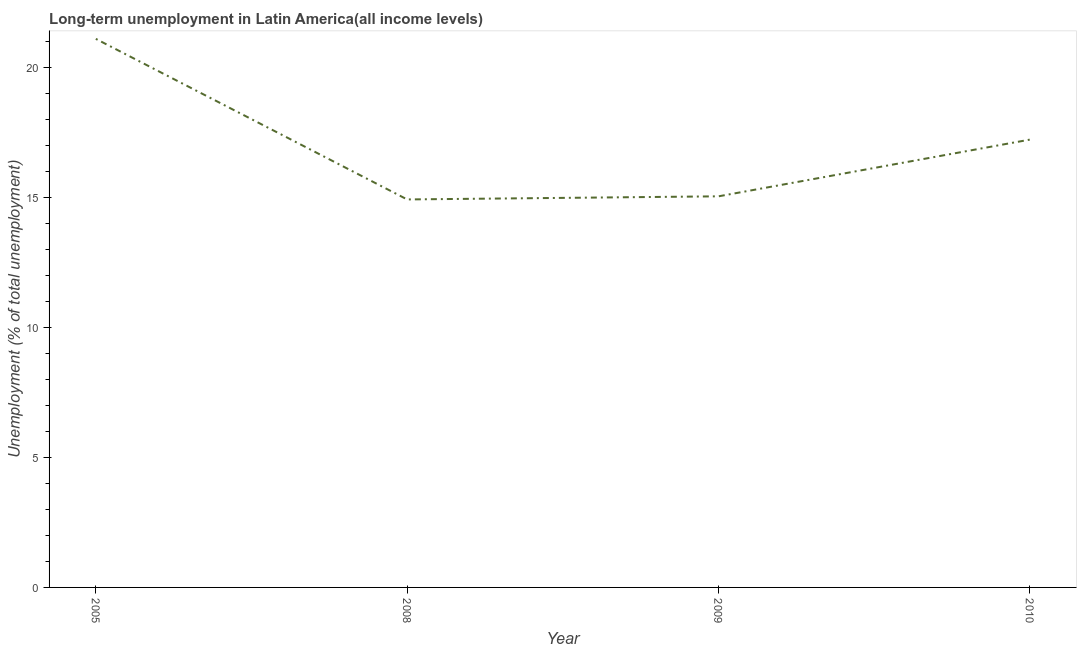What is the long-term unemployment in 2009?
Your answer should be very brief. 15.05. Across all years, what is the maximum long-term unemployment?
Provide a short and direct response. 21.11. Across all years, what is the minimum long-term unemployment?
Your response must be concise. 14.93. In which year was the long-term unemployment minimum?
Provide a succinct answer. 2008. What is the sum of the long-term unemployment?
Keep it short and to the point. 68.32. What is the difference between the long-term unemployment in 2005 and 2009?
Ensure brevity in your answer.  6.06. What is the average long-term unemployment per year?
Give a very brief answer. 17.08. What is the median long-term unemployment?
Offer a terse response. 16.14. Do a majority of the years between 2009 and 2005 (inclusive) have long-term unemployment greater than 19 %?
Make the answer very short. No. What is the ratio of the long-term unemployment in 2009 to that in 2010?
Your answer should be very brief. 0.87. What is the difference between the highest and the second highest long-term unemployment?
Provide a short and direct response. 3.88. Is the sum of the long-term unemployment in 2005 and 2009 greater than the maximum long-term unemployment across all years?
Offer a very short reply. Yes. What is the difference between the highest and the lowest long-term unemployment?
Make the answer very short. 6.18. How many lines are there?
Your answer should be very brief. 1. Are the values on the major ticks of Y-axis written in scientific E-notation?
Keep it short and to the point. No. Does the graph contain grids?
Provide a short and direct response. No. What is the title of the graph?
Your answer should be compact. Long-term unemployment in Latin America(all income levels). What is the label or title of the Y-axis?
Ensure brevity in your answer.  Unemployment (% of total unemployment). What is the Unemployment (% of total unemployment) in 2005?
Provide a succinct answer. 21.11. What is the Unemployment (% of total unemployment) in 2008?
Offer a very short reply. 14.93. What is the Unemployment (% of total unemployment) of 2009?
Give a very brief answer. 15.05. What is the Unemployment (% of total unemployment) in 2010?
Make the answer very short. 17.23. What is the difference between the Unemployment (% of total unemployment) in 2005 and 2008?
Make the answer very short. 6.18. What is the difference between the Unemployment (% of total unemployment) in 2005 and 2009?
Your answer should be compact. 6.06. What is the difference between the Unemployment (% of total unemployment) in 2005 and 2010?
Keep it short and to the point. 3.88. What is the difference between the Unemployment (% of total unemployment) in 2008 and 2009?
Keep it short and to the point. -0.12. What is the difference between the Unemployment (% of total unemployment) in 2008 and 2010?
Ensure brevity in your answer.  -2.3. What is the difference between the Unemployment (% of total unemployment) in 2009 and 2010?
Offer a very short reply. -2.18. What is the ratio of the Unemployment (% of total unemployment) in 2005 to that in 2008?
Give a very brief answer. 1.41. What is the ratio of the Unemployment (% of total unemployment) in 2005 to that in 2009?
Your response must be concise. 1.4. What is the ratio of the Unemployment (% of total unemployment) in 2005 to that in 2010?
Give a very brief answer. 1.23. What is the ratio of the Unemployment (% of total unemployment) in 2008 to that in 2010?
Offer a very short reply. 0.87. What is the ratio of the Unemployment (% of total unemployment) in 2009 to that in 2010?
Ensure brevity in your answer.  0.87. 